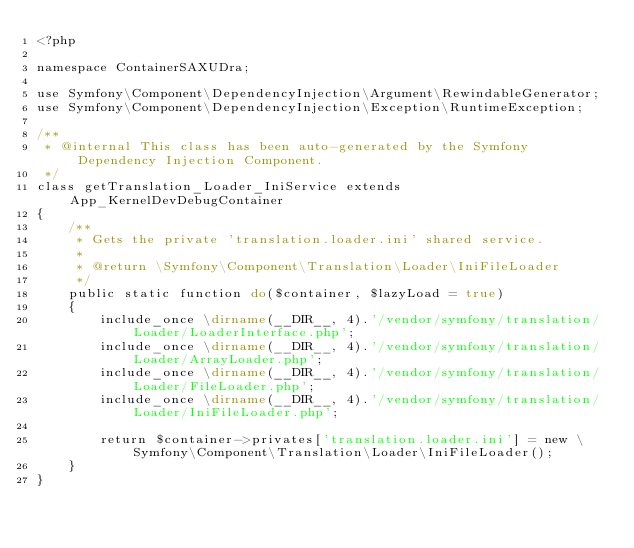Convert code to text. <code><loc_0><loc_0><loc_500><loc_500><_PHP_><?php

namespace ContainerSAXUDra;

use Symfony\Component\DependencyInjection\Argument\RewindableGenerator;
use Symfony\Component\DependencyInjection\Exception\RuntimeException;

/**
 * @internal This class has been auto-generated by the Symfony Dependency Injection Component.
 */
class getTranslation_Loader_IniService extends App_KernelDevDebugContainer
{
    /**
     * Gets the private 'translation.loader.ini' shared service.
     *
     * @return \Symfony\Component\Translation\Loader\IniFileLoader
     */
    public static function do($container, $lazyLoad = true)
    {
        include_once \dirname(__DIR__, 4).'/vendor/symfony/translation/Loader/LoaderInterface.php';
        include_once \dirname(__DIR__, 4).'/vendor/symfony/translation/Loader/ArrayLoader.php';
        include_once \dirname(__DIR__, 4).'/vendor/symfony/translation/Loader/FileLoader.php';
        include_once \dirname(__DIR__, 4).'/vendor/symfony/translation/Loader/IniFileLoader.php';

        return $container->privates['translation.loader.ini'] = new \Symfony\Component\Translation\Loader\IniFileLoader();
    }
}
</code> 